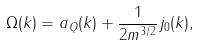Convert formula to latex. <formula><loc_0><loc_0><loc_500><loc_500>\Omega ( { k } ) = a _ { Q } ( { k } ) + \frac { 1 } { 2 m ^ { 3 / 2 } } j _ { 0 } ( { k } ) ,</formula> 